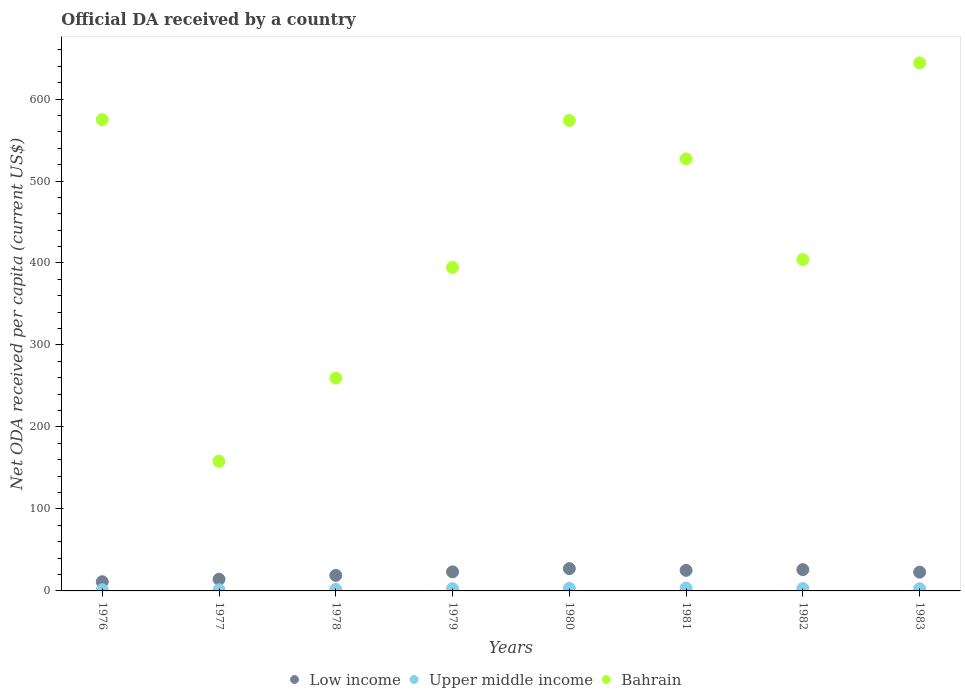What is the ODA received in in Bahrain in 1983?
Your response must be concise. 644.05. Across all years, what is the maximum ODA received in in Bahrain?
Offer a terse response. 644.05. Across all years, what is the minimum ODA received in in Low income?
Offer a terse response. 11.2. In which year was the ODA received in in Low income minimum?
Offer a very short reply. 1976. What is the total ODA received in in Bahrain in the graph?
Offer a very short reply. 3536.22. What is the difference between the ODA received in in Upper middle income in 1979 and that in 1982?
Offer a very short reply. -0.21. What is the difference between the ODA received in in Low income in 1978 and the ODA received in in Upper middle income in 1976?
Provide a succinct answer. 17.56. What is the average ODA received in in Upper middle income per year?
Your answer should be very brief. 2.47. In the year 1976, what is the difference between the ODA received in in Low income and ODA received in in Upper middle income?
Offer a terse response. 9.8. In how many years, is the ODA received in in Upper middle income greater than 560 US$?
Provide a short and direct response. 0. What is the ratio of the ODA received in in Upper middle income in 1982 to that in 1983?
Provide a short and direct response. 1.07. What is the difference between the highest and the second highest ODA received in in Low income?
Provide a short and direct response. 1.23. What is the difference between the highest and the lowest ODA received in in Low income?
Offer a very short reply. 15.99. In how many years, is the ODA received in in Bahrain greater than the average ODA received in in Bahrain taken over all years?
Make the answer very short. 4. Is the sum of the ODA received in in Bahrain in 1978 and 1982 greater than the maximum ODA received in in Low income across all years?
Provide a succinct answer. Yes. Does the ODA received in in Upper middle income monotonically increase over the years?
Provide a succinct answer. No. Is the ODA received in in Upper middle income strictly greater than the ODA received in in Low income over the years?
Your answer should be very brief. No. Is the ODA received in in Bahrain strictly less than the ODA received in in Upper middle income over the years?
Provide a succinct answer. No. How many dotlines are there?
Make the answer very short. 3. What is the difference between two consecutive major ticks on the Y-axis?
Keep it short and to the point. 100. Are the values on the major ticks of Y-axis written in scientific E-notation?
Provide a succinct answer. No. Does the graph contain any zero values?
Provide a short and direct response. No. What is the title of the graph?
Ensure brevity in your answer.  Official DA received by a country. What is the label or title of the Y-axis?
Your answer should be very brief. Net ODA received per capita (current US$). What is the Net ODA received per capita (current US$) of Low income in 1976?
Make the answer very short. 11.2. What is the Net ODA received per capita (current US$) in Upper middle income in 1976?
Your response must be concise. 1.4. What is the Net ODA received per capita (current US$) in Bahrain in 1976?
Your answer should be very brief. 574.82. What is the Net ODA received per capita (current US$) of Low income in 1977?
Provide a succinct answer. 14.23. What is the Net ODA received per capita (current US$) in Upper middle income in 1977?
Your answer should be compact. 1.33. What is the Net ODA received per capita (current US$) of Bahrain in 1977?
Your answer should be compact. 158.16. What is the Net ODA received per capita (current US$) in Low income in 1978?
Ensure brevity in your answer.  18.96. What is the Net ODA received per capita (current US$) of Upper middle income in 1978?
Ensure brevity in your answer.  1.85. What is the Net ODA received per capita (current US$) of Bahrain in 1978?
Your answer should be compact. 259.53. What is the Net ODA received per capita (current US$) of Low income in 1979?
Your answer should be compact. 23.27. What is the Net ODA received per capita (current US$) of Upper middle income in 1979?
Your answer should be very brief. 2.72. What is the Net ODA received per capita (current US$) in Bahrain in 1979?
Your answer should be compact. 394.63. What is the Net ODA received per capita (current US$) in Low income in 1980?
Provide a short and direct response. 27.18. What is the Net ODA received per capita (current US$) of Upper middle income in 1980?
Your answer should be compact. 3.27. What is the Net ODA received per capita (current US$) of Bahrain in 1980?
Keep it short and to the point. 573.85. What is the Net ODA received per capita (current US$) in Low income in 1981?
Offer a terse response. 25.1. What is the Net ODA received per capita (current US$) of Upper middle income in 1981?
Offer a terse response. 3.5. What is the Net ODA received per capita (current US$) in Bahrain in 1981?
Your answer should be compact. 526.99. What is the Net ODA received per capita (current US$) in Low income in 1982?
Your answer should be very brief. 25.95. What is the Net ODA received per capita (current US$) of Upper middle income in 1982?
Your response must be concise. 2.93. What is the Net ODA received per capita (current US$) in Bahrain in 1982?
Your response must be concise. 404.2. What is the Net ODA received per capita (current US$) in Low income in 1983?
Your answer should be compact. 22.9. What is the Net ODA received per capita (current US$) of Upper middle income in 1983?
Offer a very short reply. 2.74. What is the Net ODA received per capita (current US$) of Bahrain in 1983?
Make the answer very short. 644.05. Across all years, what is the maximum Net ODA received per capita (current US$) of Low income?
Your answer should be very brief. 27.18. Across all years, what is the maximum Net ODA received per capita (current US$) of Upper middle income?
Offer a terse response. 3.5. Across all years, what is the maximum Net ODA received per capita (current US$) in Bahrain?
Offer a very short reply. 644.05. Across all years, what is the minimum Net ODA received per capita (current US$) of Low income?
Provide a succinct answer. 11.2. Across all years, what is the minimum Net ODA received per capita (current US$) in Upper middle income?
Your answer should be compact. 1.33. Across all years, what is the minimum Net ODA received per capita (current US$) of Bahrain?
Your answer should be compact. 158.16. What is the total Net ODA received per capita (current US$) of Low income in the graph?
Your answer should be very brief. 168.79. What is the total Net ODA received per capita (current US$) in Upper middle income in the graph?
Give a very brief answer. 19.74. What is the total Net ODA received per capita (current US$) in Bahrain in the graph?
Your answer should be very brief. 3536.22. What is the difference between the Net ODA received per capita (current US$) of Low income in 1976 and that in 1977?
Your answer should be compact. -3.03. What is the difference between the Net ODA received per capita (current US$) of Upper middle income in 1976 and that in 1977?
Provide a short and direct response. 0.07. What is the difference between the Net ODA received per capita (current US$) of Bahrain in 1976 and that in 1977?
Offer a very short reply. 416.66. What is the difference between the Net ODA received per capita (current US$) in Low income in 1976 and that in 1978?
Provide a succinct answer. -7.76. What is the difference between the Net ODA received per capita (current US$) of Upper middle income in 1976 and that in 1978?
Offer a very short reply. -0.46. What is the difference between the Net ODA received per capita (current US$) in Bahrain in 1976 and that in 1978?
Offer a very short reply. 315.3. What is the difference between the Net ODA received per capita (current US$) in Low income in 1976 and that in 1979?
Offer a very short reply. -12.07. What is the difference between the Net ODA received per capita (current US$) in Upper middle income in 1976 and that in 1979?
Give a very brief answer. -1.32. What is the difference between the Net ODA received per capita (current US$) in Bahrain in 1976 and that in 1979?
Make the answer very short. 180.2. What is the difference between the Net ODA received per capita (current US$) of Low income in 1976 and that in 1980?
Your response must be concise. -15.99. What is the difference between the Net ODA received per capita (current US$) of Upper middle income in 1976 and that in 1980?
Ensure brevity in your answer.  -1.87. What is the difference between the Net ODA received per capita (current US$) of Bahrain in 1976 and that in 1980?
Give a very brief answer. 0.97. What is the difference between the Net ODA received per capita (current US$) of Low income in 1976 and that in 1981?
Your answer should be very brief. -13.9. What is the difference between the Net ODA received per capita (current US$) in Upper middle income in 1976 and that in 1981?
Make the answer very short. -2.1. What is the difference between the Net ODA received per capita (current US$) of Bahrain in 1976 and that in 1981?
Offer a very short reply. 47.84. What is the difference between the Net ODA received per capita (current US$) of Low income in 1976 and that in 1982?
Your answer should be compact. -14.75. What is the difference between the Net ODA received per capita (current US$) in Upper middle income in 1976 and that in 1982?
Provide a succinct answer. -1.53. What is the difference between the Net ODA received per capita (current US$) in Bahrain in 1976 and that in 1982?
Your answer should be compact. 170.63. What is the difference between the Net ODA received per capita (current US$) in Low income in 1976 and that in 1983?
Keep it short and to the point. -11.71. What is the difference between the Net ODA received per capita (current US$) of Upper middle income in 1976 and that in 1983?
Provide a short and direct response. -1.35. What is the difference between the Net ODA received per capita (current US$) in Bahrain in 1976 and that in 1983?
Give a very brief answer. -69.22. What is the difference between the Net ODA received per capita (current US$) in Low income in 1977 and that in 1978?
Offer a very short reply. -4.73. What is the difference between the Net ODA received per capita (current US$) in Upper middle income in 1977 and that in 1978?
Provide a succinct answer. -0.53. What is the difference between the Net ODA received per capita (current US$) of Bahrain in 1977 and that in 1978?
Make the answer very short. -101.37. What is the difference between the Net ODA received per capita (current US$) of Low income in 1977 and that in 1979?
Give a very brief answer. -9.04. What is the difference between the Net ODA received per capita (current US$) of Upper middle income in 1977 and that in 1979?
Keep it short and to the point. -1.39. What is the difference between the Net ODA received per capita (current US$) in Bahrain in 1977 and that in 1979?
Offer a terse response. -236.47. What is the difference between the Net ODA received per capita (current US$) of Low income in 1977 and that in 1980?
Keep it short and to the point. -12.96. What is the difference between the Net ODA received per capita (current US$) in Upper middle income in 1977 and that in 1980?
Ensure brevity in your answer.  -1.94. What is the difference between the Net ODA received per capita (current US$) of Bahrain in 1977 and that in 1980?
Make the answer very short. -415.69. What is the difference between the Net ODA received per capita (current US$) of Low income in 1977 and that in 1981?
Provide a succinct answer. -10.88. What is the difference between the Net ODA received per capita (current US$) in Upper middle income in 1977 and that in 1981?
Offer a very short reply. -2.17. What is the difference between the Net ODA received per capita (current US$) in Bahrain in 1977 and that in 1981?
Your answer should be very brief. -368.83. What is the difference between the Net ODA received per capita (current US$) of Low income in 1977 and that in 1982?
Your answer should be very brief. -11.73. What is the difference between the Net ODA received per capita (current US$) in Upper middle income in 1977 and that in 1982?
Provide a succinct answer. -1.6. What is the difference between the Net ODA received per capita (current US$) in Bahrain in 1977 and that in 1982?
Offer a very short reply. -246.04. What is the difference between the Net ODA received per capita (current US$) of Low income in 1977 and that in 1983?
Provide a short and direct response. -8.68. What is the difference between the Net ODA received per capita (current US$) of Upper middle income in 1977 and that in 1983?
Ensure brevity in your answer.  -1.41. What is the difference between the Net ODA received per capita (current US$) in Bahrain in 1977 and that in 1983?
Keep it short and to the point. -485.89. What is the difference between the Net ODA received per capita (current US$) of Low income in 1978 and that in 1979?
Your answer should be very brief. -4.31. What is the difference between the Net ODA received per capita (current US$) in Upper middle income in 1978 and that in 1979?
Your answer should be compact. -0.87. What is the difference between the Net ODA received per capita (current US$) in Bahrain in 1978 and that in 1979?
Your answer should be very brief. -135.1. What is the difference between the Net ODA received per capita (current US$) in Low income in 1978 and that in 1980?
Provide a succinct answer. -8.23. What is the difference between the Net ODA received per capita (current US$) in Upper middle income in 1978 and that in 1980?
Keep it short and to the point. -1.41. What is the difference between the Net ODA received per capita (current US$) in Bahrain in 1978 and that in 1980?
Offer a terse response. -314.32. What is the difference between the Net ODA received per capita (current US$) of Low income in 1978 and that in 1981?
Give a very brief answer. -6.14. What is the difference between the Net ODA received per capita (current US$) of Upper middle income in 1978 and that in 1981?
Your response must be concise. -1.64. What is the difference between the Net ODA received per capita (current US$) of Bahrain in 1978 and that in 1981?
Your answer should be very brief. -267.46. What is the difference between the Net ODA received per capita (current US$) of Low income in 1978 and that in 1982?
Make the answer very short. -6.99. What is the difference between the Net ODA received per capita (current US$) in Upper middle income in 1978 and that in 1982?
Give a very brief answer. -1.07. What is the difference between the Net ODA received per capita (current US$) of Bahrain in 1978 and that in 1982?
Provide a short and direct response. -144.67. What is the difference between the Net ODA received per capita (current US$) of Low income in 1978 and that in 1983?
Keep it short and to the point. -3.95. What is the difference between the Net ODA received per capita (current US$) of Upper middle income in 1978 and that in 1983?
Your response must be concise. -0.89. What is the difference between the Net ODA received per capita (current US$) of Bahrain in 1978 and that in 1983?
Make the answer very short. -384.52. What is the difference between the Net ODA received per capita (current US$) of Low income in 1979 and that in 1980?
Your response must be concise. -3.92. What is the difference between the Net ODA received per capita (current US$) of Upper middle income in 1979 and that in 1980?
Provide a short and direct response. -0.55. What is the difference between the Net ODA received per capita (current US$) of Bahrain in 1979 and that in 1980?
Your answer should be compact. -179.22. What is the difference between the Net ODA received per capita (current US$) in Low income in 1979 and that in 1981?
Make the answer very short. -1.83. What is the difference between the Net ODA received per capita (current US$) of Upper middle income in 1979 and that in 1981?
Your answer should be compact. -0.78. What is the difference between the Net ODA received per capita (current US$) of Bahrain in 1979 and that in 1981?
Your answer should be very brief. -132.36. What is the difference between the Net ODA received per capita (current US$) in Low income in 1979 and that in 1982?
Give a very brief answer. -2.68. What is the difference between the Net ODA received per capita (current US$) in Upper middle income in 1979 and that in 1982?
Provide a succinct answer. -0.21. What is the difference between the Net ODA received per capita (current US$) of Bahrain in 1979 and that in 1982?
Provide a short and direct response. -9.57. What is the difference between the Net ODA received per capita (current US$) of Low income in 1979 and that in 1983?
Your answer should be very brief. 0.36. What is the difference between the Net ODA received per capita (current US$) in Upper middle income in 1979 and that in 1983?
Your response must be concise. -0.02. What is the difference between the Net ODA received per capita (current US$) in Bahrain in 1979 and that in 1983?
Your answer should be very brief. -249.42. What is the difference between the Net ODA received per capita (current US$) of Low income in 1980 and that in 1981?
Your response must be concise. 2.08. What is the difference between the Net ODA received per capita (current US$) of Upper middle income in 1980 and that in 1981?
Your answer should be compact. -0.23. What is the difference between the Net ODA received per capita (current US$) of Bahrain in 1980 and that in 1981?
Keep it short and to the point. 46.86. What is the difference between the Net ODA received per capita (current US$) of Low income in 1980 and that in 1982?
Provide a short and direct response. 1.23. What is the difference between the Net ODA received per capita (current US$) of Upper middle income in 1980 and that in 1982?
Your answer should be very brief. 0.34. What is the difference between the Net ODA received per capita (current US$) of Bahrain in 1980 and that in 1982?
Your answer should be very brief. 169.65. What is the difference between the Net ODA received per capita (current US$) in Low income in 1980 and that in 1983?
Offer a terse response. 4.28. What is the difference between the Net ODA received per capita (current US$) of Upper middle income in 1980 and that in 1983?
Give a very brief answer. 0.53. What is the difference between the Net ODA received per capita (current US$) of Bahrain in 1980 and that in 1983?
Your response must be concise. -70.2. What is the difference between the Net ODA received per capita (current US$) of Low income in 1981 and that in 1982?
Provide a succinct answer. -0.85. What is the difference between the Net ODA received per capita (current US$) in Upper middle income in 1981 and that in 1982?
Ensure brevity in your answer.  0.57. What is the difference between the Net ODA received per capita (current US$) of Bahrain in 1981 and that in 1982?
Provide a succinct answer. 122.79. What is the difference between the Net ODA received per capita (current US$) of Low income in 1981 and that in 1983?
Provide a short and direct response. 2.2. What is the difference between the Net ODA received per capita (current US$) in Upper middle income in 1981 and that in 1983?
Your answer should be very brief. 0.76. What is the difference between the Net ODA received per capita (current US$) of Bahrain in 1981 and that in 1983?
Your response must be concise. -117.06. What is the difference between the Net ODA received per capita (current US$) of Low income in 1982 and that in 1983?
Your answer should be compact. 3.05. What is the difference between the Net ODA received per capita (current US$) of Upper middle income in 1982 and that in 1983?
Ensure brevity in your answer.  0.18. What is the difference between the Net ODA received per capita (current US$) of Bahrain in 1982 and that in 1983?
Ensure brevity in your answer.  -239.85. What is the difference between the Net ODA received per capita (current US$) of Low income in 1976 and the Net ODA received per capita (current US$) of Upper middle income in 1977?
Give a very brief answer. 9.87. What is the difference between the Net ODA received per capita (current US$) in Low income in 1976 and the Net ODA received per capita (current US$) in Bahrain in 1977?
Provide a succinct answer. -146.96. What is the difference between the Net ODA received per capita (current US$) of Upper middle income in 1976 and the Net ODA received per capita (current US$) of Bahrain in 1977?
Offer a very short reply. -156.76. What is the difference between the Net ODA received per capita (current US$) of Low income in 1976 and the Net ODA received per capita (current US$) of Upper middle income in 1978?
Offer a terse response. 9.34. What is the difference between the Net ODA received per capita (current US$) in Low income in 1976 and the Net ODA received per capita (current US$) in Bahrain in 1978?
Give a very brief answer. -248.33. What is the difference between the Net ODA received per capita (current US$) in Upper middle income in 1976 and the Net ODA received per capita (current US$) in Bahrain in 1978?
Make the answer very short. -258.13. What is the difference between the Net ODA received per capita (current US$) of Low income in 1976 and the Net ODA received per capita (current US$) of Upper middle income in 1979?
Your answer should be very brief. 8.48. What is the difference between the Net ODA received per capita (current US$) in Low income in 1976 and the Net ODA received per capita (current US$) in Bahrain in 1979?
Make the answer very short. -383.43. What is the difference between the Net ODA received per capita (current US$) in Upper middle income in 1976 and the Net ODA received per capita (current US$) in Bahrain in 1979?
Make the answer very short. -393.23. What is the difference between the Net ODA received per capita (current US$) of Low income in 1976 and the Net ODA received per capita (current US$) of Upper middle income in 1980?
Your response must be concise. 7.93. What is the difference between the Net ODA received per capita (current US$) of Low income in 1976 and the Net ODA received per capita (current US$) of Bahrain in 1980?
Keep it short and to the point. -562.65. What is the difference between the Net ODA received per capita (current US$) of Upper middle income in 1976 and the Net ODA received per capita (current US$) of Bahrain in 1980?
Make the answer very short. -572.45. What is the difference between the Net ODA received per capita (current US$) in Low income in 1976 and the Net ODA received per capita (current US$) in Upper middle income in 1981?
Your response must be concise. 7.7. What is the difference between the Net ODA received per capita (current US$) in Low income in 1976 and the Net ODA received per capita (current US$) in Bahrain in 1981?
Offer a terse response. -515.79. What is the difference between the Net ODA received per capita (current US$) in Upper middle income in 1976 and the Net ODA received per capita (current US$) in Bahrain in 1981?
Your response must be concise. -525.59. What is the difference between the Net ODA received per capita (current US$) in Low income in 1976 and the Net ODA received per capita (current US$) in Upper middle income in 1982?
Offer a very short reply. 8.27. What is the difference between the Net ODA received per capita (current US$) in Low income in 1976 and the Net ODA received per capita (current US$) in Bahrain in 1982?
Your answer should be compact. -393. What is the difference between the Net ODA received per capita (current US$) in Upper middle income in 1976 and the Net ODA received per capita (current US$) in Bahrain in 1982?
Keep it short and to the point. -402.8. What is the difference between the Net ODA received per capita (current US$) in Low income in 1976 and the Net ODA received per capita (current US$) in Upper middle income in 1983?
Your response must be concise. 8.46. What is the difference between the Net ODA received per capita (current US$) in Low income in 1976 and the Net ODA received per capita (current US$) in Bahrain in 1983?
Offer a terse response. -632.85. What is the difference between the Net ODA received per capita (current US$) in Upper middle income in 1976 and the Net ODA received per capita (current US$) in Bahrain in 1983?
Offer a terse response. -642.65. What is the difference between the Net ODA received per capita (current US$) of Low income in 1977 and the Net ODA received per capita (current US$) of Upper middle income in 1978?
Your answer should be very brief. 12.37. What is the difference between the Net ODA received per capita (current US$) of Low income in 1977 and the Net ODA received per capita (current US$) of Bahrain in 1978?
Provide a short and direct response. -245.3. What is the difference between the Net ODA received per capita (current US$) in Upper middle income in 1977 and the Net ODA received per capita (current US$) in Bahrain in 1978?
Provide a succinct answer. -258.2. What is the difference between the Net ODA received per capita (current US$) in Low income in 1977 and the Net ODA received per capita (current US$) in Upper middle income in 1979?
Offer a very short reply. 11.5. What is the difference between the Net ODA received per capita (current US$) of Low income in 1977 and the Net ODA received per capita (current US$) of Bahrain in 1979?
Your answer should be very brief. -380.4. What is the difference between the Net ODA received per capita (current US$) in Upper middle income in 1977 and the Net ODA received per capita (current US$) in Bahrain in 1979?
Your answer should be very brief. -393.3. What is the difference between the Net ODA received per capita (current US$) of Low income in 1977 and the Net ODA received per capita (current US$) of Upper middle income in 1980?
Provide a succinct answer. 10.96. What is the difference between the Net ODA received per capita (current US$) of Low income in 1977 and the Net ODA received per capita (current US$) of Bahrain in 1980?
Your answer should be compact. -559.63. What is the difference between the Net ODA received per capita (current US$) in Upper middle income in 1977 and the Net ODA received per capita (current US$) in Bahrain in 1980?
Ensure brevity in your answer.  -572.52. What is the difference between the Net ODA received per capita (current US$) in Low income in 1977 and the Net ODA received per capita (current US$) in Upper middle income in 1981?
Offer a very short reply. 10.73. What is the difference between the Net ODA received per capita (current US$) of Low income in 1977 and the Net ODA received per capita (current US$) of Bahrain in 1981?
Give a very brief answer. -512.76. What is the difference between the Net ODA received per capita (current US$) of Upper middle income in 1977 and the Net ODA received per capita (current US$) of Bahrain in 1981?
Provide a short and direct response. -525.66. What is the difference between the Net ODA received per capita (current US$) of Low income in 1977 and the Net ODA received per capita (current US$) of Upper middle income in 1982?
Offer a very short reply. 11.3. What is the difference between the Net ODA received per capita (current US$) in Low income in 1977 and the Net ODA received per capita (current US$) in Bahrain in 1982?
Provide a short and direct response. -389.97. What is the difference between the Net ODA received per capita (current US$) in Upper middle income in 1977 and the Net ODA received per capita (current US$) in Bahrain in 1982?
Offer a terse response. -402.87. What is the difference between the Net ODA received per capita (current US$) of Low income in 1977 and the Net ODA received per capita (current US$) of Upper middle income in 1983?
Keep it short and to the point. 11.48. What is the difference between the Net ODA received per capita (current US$) in Low income in 1977 and the Net ODA received per capita (current US$) in Bahrain in 1983?
Make the answer very short. -629.82. What is the difference between the Net ODA received per capita (current US$) in Upper middle income in 1977 and the Net ODA received per capita (current US$) in Bahrain in 1983?
Offer a very short reply. -642.72. What is the difference between the Net ODA received per capita (current US$) of Low income in 1978 and the Net ODA received per capita (current US$) of Upper middle income in 1979?
Your answer should be very brief. 16.24. What is the difference between the Net ODA received per capita (current US$) of Low income in 1978 and the Net ODA received per capita (current US$) of Bahrain in 1979?
Provide a succinct answer. -375.67. What is the difference between the Net ODA received per capita (current US$) of Upper middle income in 1978 and the Net ODA received per capita (current US$) of Bahrain in 1979?
Give a very brief answer. -392.77. What is the difference between the Net ODA received per capita (current US$) in Low income in 1978 and the Net ODA received per capita (current US$) in Upper middle income in 1980?
Your answer should be very brief. 15.69. What is the difference between the Net ODA received per capita (current US$) in Low income in 1978 and the Net ODA received per capita (current US$) in Bahrain in 1980?
Your answer should be compact. -554.89. What is the difference between the Net ODA received per capita (current US$) of Upper middle income in 1978 and the Net ODA received per capita (current US$) of Bahrain in 1980?
Provide a succinct answer. -572. What is the difference between the Net ODA received per capita (current US$) of Low income in 1978 and the Net ODA received per capita (current US$) of Upper middle income in 1981?
Your response must be concise. 15.46. What is the difference between the Net ODA received per capita (current US$) in Low income in 1978 and the Net ODA received per capita (current US$) in Bahrain in 1981?
Make the answer very short. -508.03. What is the difference between the Net ODA received per capita (current US$) in Upper middle income in 1978 and the Net ODA received per capita (current US$) in Bahrain in 1981?
Offer a terse response. -525.14. What is the difference between the Net ODA received per capita (current US$) in Low income in 1978 and the Net ODA received per capita (current US$) in Upper middle income in 1982?
Give a very brief answer. 16.03. What is the difference between the Net ODA received per capita (current US$) in Low income in 1978 and the Net ODA received per capita (current US$) in Bahrain in 1982?
Provide a short and direct response. -385.24. What is the difference between the Net ODA received per capita (current US$) in Upper middle income in 1978 and the Net ODA received per capita (current US$) in Bahrain in 1982?
Offer a terse response. -402.34. What is the difference between the Net ODA received per capita (current US$) of Low income in 1978 and the Net ODA received per capita (current US$) of Upper middle income in 1983?
Make the answer very short. 16.22. What is the difference between the Net ODA received per capita (current US$) in Low income in 1978 and the Net ODA received per capita (current US$) in Bahrain in 1983?
Provide a succinct answer. -625.09. What is the difference between the Net ODA received per capita (current US$) of Upper middle income in 1978 and the Net ODA received per capita (current US$) of Bahrain in 1983?
Offer a terse response. -642.19. What is the difference between the Net ODA received per capita (current US$) of Low income in 1979 and the Net ODA received per capita (current US$) of Upper middle income in 1980?
Keep it short and to the point. 20. What is the difference between the Net ODA received per capita (current US$) of Low income in 1979 and the Net ODA received per capita (current US$) of Bahrain in 1980?
Offer a terse response. -550.58. What is the difference between the Net ODA received per capita (current US$) of Upper middle income in 1979 and the Net ODA received per capita (current US$) of Bahrain in 1980?
Make the answer very short. -571.13. What is the difference between the Net ODA received per capita (current US$) of Low income in 1979 and the Net ODA received per capita (current US$) of Upper middle income in 1981?
Your response must be concise. 19.77. What is the difference between the Net ODA received per capita (current US$) in Low income in 1979 and the Net ODA received per capita (current US$) in Bahrain in 1981?
Your answer should be compact. -503.72. What is the difference between the Net ODA received per capita (current US$) of Upper middle income in 1979 and the Net ODA received per capita (current US$) of Bahrain in 1981?
Ensure brevity in your answer.  -524.27. What is the difference between the Net ODA received per capita (current US$) of Low income in 1979 and the Net ODA received per capita (current US$) of Upper middle income in 1982?
Provide a short and direct response. 20.34. What is the difference between the Net ODA received per capita (current US$) of Low income in 1979 and the Net ODA received per capita (current US$) of Bahrain in 1982?
Keep it short and to the point. -380.93. What is the difference between the Net ODA received per capita (current US$) of Upper middle income in 1979 and the Net ODA received per capita (current US$) of Bahrain in 1982?
Offer a very short reply. -401.48. What is the difference between the Net ODA received per capita (current US$) of Low income in 1979 and the Net ODA received per capita (current US$) of Upper middle income in 1983?
Give a very brief answer. 20.52. What is the difference between the Net ODA received per capita (current US$) of Low income in 1979 and the Net ODA received per capita (current US$) of Bahrain in 1983?
Give a very brief answer. -620.78. What is the difference between the Net ODA received per capita (current US$) of Upper middle income in 1979 and the Net ODA received per capita (current US$) of Bahrain in 1983?
Provide a succinct answer. -641.32. What is the difference between the Net ODA received per capita (current US$) of Low income in 1980 and the Net ODA received per capita (current US$) of Upper middle income in 1981?
Provide a succinct answer. 23.69. What is the difference between the Net ODA received per capita (current US$) of Low income in 1980 and the Net ODA received per capita (current US$) of Bahrain in 1981?
Ensure brevity in your answer.  -499.8. What is the difference between the Net ODA received per capita (current US$) in Upper middle income in 1980 and the Net ODA received per capita (current US$) in Bahrain in 1981?
Keep it short and to the point. -523.72. What is the difference between the Net ODA received per capita (current US$) of Low income in 1980 and the Net ODA received per capita (current US$) of Upper middle income in 1982?
Your answer should be compact. 24.26. What is the difference between the Net ODA received per capita (current US$) of Low income in 1980 and the Net ODA received per capita (current US$) of Bahrain in 1982?
Your response must be concise. -377.01. What is the difference between the Net ODA received per capita (current US$) in Upper middle income in 1980 and the Net ODA received per capita (current US$) in Bahrain in 1982?
Offer a terse response. -400.93. What is the difference between the Net ODA received per capita (current US$) in Low income in 1980 and the Net ODA received per capita (current US$) in Upper middle income in 1983?
Give a very brief answer. 24.44. What is the difference between the Net ODA received per capita (current US$) in Low income in 1980 and the Net ODA received per capita (current US$) in Bahrain in 1983?
Your answer should be very brief. -616.86. What is the difference between the Net ODA received per capita (current US$) in Upper middle income in 1980 and the Net ODA received per capita (current US$) in Bahrain in 1983?
Your answer should be compact. -640.78. What is the difference between the Net ODA received per capita (current US$) in Low income in 1981 and the Net ODA received per capita (current US$) in Upper middle income in 1982?
Keep it short and to the point. 22.17. What is the difference between the Net ODA received per capita (current US$) in Low income in 1981 and the Net ODA received per capita (current US$) in Bahrain in 1982?
Ensure brevity in your answer.  -379.1. What is the difference between the Net ODA received per capita (current US$) in Upper middle income in 1981 and the Net ODA received per capita (current US$) in Bahrain in 1982?
Your answer should be very brief. -400.7. What is the difference between the Net ODA received per capita (current US$) in Low income in 1981 and the Net ODA received per capita (current US$) in Upper middle income in 1983?
Provide a short and direct response. 22.36. What is the difference between the Net ODA received per capita (current US$) of Low income in 1981 and the Net ODA received per capita (current US$) of Bahrain in 1983?
Your answer should be very brief. -618.94. What is the difference between the Net ODA received per capita (current US$) of Upper middle income in 1981 and the Net ODA received per capita (current US$) of Bahrain in 1983?
Provide a succinct answer. -640.55. What is the difference between the Net ODA received per capita (current US$) in Low income in 1982 and the Net ODA received per capita (current US$) in Upper middle income in 1983?
Keep it short and to the point. 23.21. What is the difference between the Net ODA received per capita (current US$) in Low income in 1982 and the Net ODA received per capita (current US$) in Bahrain in 1983?
Your response must be concise. -618.09. What is the difference between the Net ODA received per capita (current US$) of Upper middle income in 1982 and the Net ODA received per capita (current US$) of Bahrain in 1983?
Ensure brevity in your answer.  -641.12. What is the average Net ODA received per capita (current US$) of Low income per year?
Your answer should be very brief. 21.1. What is the average Net ODA received per capita (current US$) of Upper middle income per year?
Offer a terse response. 2.47. What is the average Net ODA received per capita (current US$) of Bahrain per year?
Offer a terse response. 442.03. In the year 1976, what is the difference between the Net ODA received per capita (current US$) in Low income and Net ODA received per capita (current US$) in Upper middle income?
Provide a succinct answer. 9.8. In the year 1976, what is the difference between the Net ODA received per capita (current US$) of Low income and Net ODA received per capita (current US$) of Bahrain?
Ensure brevity in your answer.  -563.63. In the year 1976, what is the difference between the Net ODA received per capita (current US$) in Upper middle income and Net ODA received per capita (current US$) in Bahrain?
Offer a very short reply. -573.43. In the year 1977, what is the difference between the Net ODA received per capita (current US$) of Low income and Net ODA received per capita (current US$) of Upper middle income?
Make the answer very short. 12.9. In the year 1977, what is the difference between the Net ODA received per capita (current US$) of Low income and Net ODA received per capita (current US$) of Bahrain?
Offer a terse response. -143.94. In the year 1977, what is the difference between the Net ODA received per capita (current US$) in Upper middle income and Net ODA received per capita (current US$) in Bahrain?
Provide a succinct answer. -156.83. In the year 1978, what is the difference between the Net ODA received per capita (current US$) in Low income and Net ODA received per capita (current US$) in Upper middle income?
Provide a short and direct response. 17.1. In the year 1978, what is the difference between the Net ODA received per capita (current US$) of Low income and Net ODA received per capita (current US$) of Bahrain?
Offer a terse response. -240.57. In the year 1978, what is the difference between the Net ODA received per capita (current US$) of Upper middle income and Net ODA received per capita (current US$) of Bahrain?
Make the answer very short. -257.67. In the year 1979, what is the difference between the Net ODA received per capita (current US$) in Low income and Net ODA received per capita (current US$) in Upper middle income?
Provide a short and direct response. 20.55. In the year 1979, what is the difference between the Net ODA received per capita (current US$) of Low income and Net ODA received per capita (current US$) of Bahrain?
Ensure brevity in your answer.  -371.36. In the year 1979, what is the difference between the Net ODA received per capita (current US$) in Upper middle income and Net ODA received per capita (current US$) in Bahrain?
Offer a very short reply. -391.91. In the year 1980, what is the difference between the Net ODA received per capita (current US$) of Low income and Net ODA received per capita (current US$) of Upper middle income?
Provide a succinct answer. 23.92. In the year 1980, what is the difference between the Net ODA received per capita (current US$) in Low income and Net ODA received per capita (current US$) in Bahrain?
Ensure brevity in your answer.  -546.67. In the year 1980, what is the difference between the Net ODA received per capita (current US$) in Upper middle income and Net ODA received per capita (current US$) in Bahrain?
Your response must be concise. -570.58. In the year 1981, what is the difference between the Net ODA received per capita (current US$) in Low income and Net ODA received per capita (current US$) in Upper middle income?
Your response must be concise. 21.6. In the year 1981, what is the difference between the Net ODA received per capita (current US$) of Low income and Net ODA received per capita (current US$) of Bahrain?
Your response must be concise. -501.89. In the year 1981, what is the difference between the Net ODA received per capita (current US$) of Upper middle income and Net ODA received per capita (current US$) of Bahrain?
Your response must be concise. -523.49. In the year 1982, what is the difference between the Net ODA received per capita (current US$) in Low income and Net ODA received per capita (current US$) in Upper middle income?
Your answer should be very brief. 23.02. In the year 1982, what is the difference between the Net ODA received per capita (current US$) in Low income and Net ODA received per capita (current US$) in Bahrain?
Provide a succinct answer. -378.25. In the year 1982, what is the difference between the Net ODA received per capita (current US$) in Upper middle income and Net ODA received per capita (current US$) in Bahrain?
Provide a succinct answer. -401.27. In the year 1983, what is the difference between the Net ODA received per capita (current US$) in Low income and Net ODA received per capita (current US$) in Upper middle income?
Offer a very short reply. 20.16. In the year 1983, what is the difference between the Net ODA received per capita (current US$) in Low income and Net ODA received per capita (current US$) in Bahrain?
Provide a succinct answer. -621.14. In the year 1983, what is the difference between the Net ODA received per capita (current US$) in Upper middle income and Net ODA received per capita (current US$) in Bahrain?
Keep it short and to the point. -641.3. What is the ratio of the Net ODA received per capita (current US$) in Low income in 1976 to that in 1977?
Your response must be concise. 0.79. What is the ratio of the Net ODA received per capita (current US$) in Upper middle income in 1976 to that in 1977?
Your answer should be very brief. 1.05. What is the ratio of the Net ODA received per capita (current US$) in Bahrain in 1976 to that in 1977?
Your response must be concise. 3.63. What is the ratio of the Net ODA received per capita (current US$) in Low income in 1976 to that in 1978?
Keep it short and to the point. 0.59. What is the ratio of the Net ODA received per capita (current US$) of Upper middle income in 1976 to that in 1978?
Your answer should be very brief. 0.75. What is the ratio of the Net ODA received per capita (current US$) of Bahrain in 1976 to that in 1978?
Provide a succinct answer. 2.21. What is the ratio of the Net ODA received per capita (current US$) of Low income in 1976 to that in 1979?
Give a very brief answer. 0.48. What is the ratio of the Net ODA received per capita (current US$) in Upper middle income in 1976 to that in 1979?
Your response must be concise. 0.51. What is the ratio of the Net ODA received per capita (current US$) in Bahrain in 1976 to that in 1979?
Your response must be concise. 1.46. What is the ratio of the Net ODA received per capita (current US$) in Low income in 1976 to that in 1980?
Your answer should be very brief. 0.41. What is the ratio of the Net ODA received per capita (current US$) of Upper middle income in 1976 to that in 1980?
Provide a short and direct response. 0.43. What is the ratio of the Net ODA received per capita (current US$) in Bahrain in 1976 to that in 1980?
Your answer should be compact. 1. What is the ratio of the Net ODA received per capita (current US$) of Low income in 1976 to that in 1981?
Ensure brevity in your answer.  0.45. What is the ratio of the Net ODA received per capita (current US$) in Upper middle income in 1976 to that in 1981?
Provide a short and direct response. 0.4. What is the ratio of the Net ODA received per capita (current US$) of Bahrain in 1976 to that in 1981?
Your answer should be compact. 1.09. What is the ratio of the Net ODA received per capita (current US$) in Low income in 1976 to that in 1982?
Provide a succinct answer. 0.43. What is the ratio of the Net ODA received per capita (current US$) in Upper middle income in 1976 to that in 1982?
Ensure brevity in your answer.  0.48. What is the ratio of the Net ODA received per capita (current US$) in Bahrain in 1976 to that in 1982?
Provide a succinct answer. 1.42. What is the ratio of the Net ODA received per capita (current US$) of Low income in 1976 to that in 1983?
Keep it short and to the point. 0.49. What is the ratio of the Net ODA received per capita (current US$) of Upper middle income in 1976 to that in 1983?
Your answer should be compact. 0.51. What is the ratio of the Net ODA received per capita (current US$) in Bahrain in 1976 to that in 1983?
Your answer should be compact. 0.89. What is the ratio of the Net ODA received per capita (current US$) in Low income in 1977 to that in 1978?
Your answer should be compact. 0.75. What is the ratio of the Net ODA received per capita (current US$) of Upper middle income in 1977 to that in 1978?
Offer a terse response. 0.72. What is the ratio of the Net ODA received per capita (current US$) in Bahrain in 1977 to that in 1978?
Your answer should be very brief. 0.61. What is the ratio of the Net ODA received per capita (current US$) in Low income in 1977 to that in 1979?
Offer a very short reply. 0.61. What is the ratio of the Net ODA received per capita (current US$) of Upper middle income in 1977 to that in 1979?
Your answer should be compact. 0.49. What is the ratio of the Net ODA received per capita (current US$) in Bahrain in 1977 to that in 1979?
Your answer should be very brief. 0.4. What is the ratio of the Net ODA received per capita (current US$) in Low income in 1977 to that in 1980?
Your answer should be compact. 0.52. What is the ratio of the Net ODA received per capita (current US$) of Upper middle income in 1977 to that in 1980?
Your answer should be compact. 0.41. What is the ratio of the Net ODA received per capita (current US$) of Bahrain in 1977 to that in 1980?
Make the answer very short. 0.28. What is the ratio of the Net ODA received per capita (current US$) in Low income in 1977 to that in 1981?
Provide a succinct answer. 0.57. What is the ratio of the Net ODA received per capita (current US$) of Upper middle income in 1977 to that in 1981?
Provide a short and direct response. 0.38. What is the ratio of the Net ODA received per capita (current US$) in Bahrain in 1977 to that in 1981?
Offer a terse response. 0.3. What is the ratio of the Net ODA received per capita (current US$) in Low income in 1977 to that in 1982?
Ensure brevity in your answer.  0.55. What is the ratio of the Net ODA received per capita (current US$) of Upper middle income in 1977 to that in 1982?
Make the answer very short. 0.45. What is the ratio of the Net ODA received per capita (current US$) in Bahrain in 1977 to that in 1982?
Your response must be concise. 0.39. What is the ratio of the Net ODA received per capita (current US$) in Low income in 1977 to that in 1983?
Your answer should be very brief. 0.62. What is the ratio of the Net ODA received per capita (current US$) of Upper middle income in 1977 to that in 1983?
Your answer should be very brief. 0.48. What is the ratio of the Net ODA received per capita (current US$) in Bahrain in 1977 to that in 1983?
Your answer should be compact. 0.25. What is the ratio of the Net ODA received per capita (current US$) in Low income in 1978 to that in 1979?
Offer a very short reply. 0.81. What is the ratio of the Net ODA received per capita (current US$) in Upper middle income in 1978 to that in 1979?
Your answer should be compact. 0.68. What is the ratio of the Net ODA received per capita (current US$) of Bahrain in 1978 to that in 1979?
Your answer should be very brief. 0.66. What is the ratio of the Net ODA received per capita (current US$) of Low income in 1978 to that in 1980?
Your response must be concise. 0.7. What is the ratio of the Net ODA received per capita (current US$) of Upper middle income in 1978 to that in 1980?
Provide a short and direct response. 0.57. What is the ratio of the Net ODA received per capita (current US$) in Bahrain in 1978 to that in 1980?
Offer a very short reply. 0.45. What is the ratio of the Net ODA received per capita (current US$) of Low income in 1978 to that in 1981?
Make the answer very short. 0.76. What is the ratio of the Net ODA received per capita (current US$) of Upper middle income in 1978 to that in 1981?
Offer a terse response. 0.53. What is the ratio of the Net ODA received per capita (current US$) of Bahrain in 1978 to that in 1981?
Offer a terse response. 0.49. What is the ratio of the Net ODA received per capita (current US$) of Low income in 1978 to that in 1982?
Offer a very short reply. 0.73. What is the ratio of the Net ODA received per capita (current US$) in Upper middle income in 1978 to that in 1982?
Ensure brevity in your answer.  0.63. What is the ratio of the Net ODA received per capita (current US$) in Bahrain in 1978 to that in 1982?
Your answer should be very brief. 0.64. What is the ratio of the Net ODA received per capita (current US$) in Low income in 1978 to that in 1983?
Your answer should be compact. 0.83. What is the ratio of the Net ODA received per capita (current US$) in Upper middle income in 1978 to that in 1983?
Your answer should be compact. 0.68. What is the ratio of the Net ODA received per capita (current US$) in Bahrain in 1978 to that in 1983?
Make the answer very short. 0.4. What is the ratio of the Net ODA received per capita (current US$) in Low income in 1979 to that in 1980?
Ensure brevity in your answer.  0.86. What is the ratio of the Net ODA received per capita (current US$) in Upper middle income in 1979 to that in 1980?
Offer a very short reply. 0.83. What is the ratio of the Net ODA received per capita (current US$) in Bahrain in 1979 to that in 1980?
Offer a terse response. 0.69. What is the ratio of the Net ODA received per capita (current US$) of Low income in 1979 to that in 1981?
Your answer should be compact. 0.93. What is the ratio of the Net ODA received per capita (current US$) in Upper middle income in 1979 to that in 1981?
Make the answer very short. 0.78. What is the ratio of the Net ODA received per capita (current US$) in Bahrain in 1979 to that in 1981?
Offer a very short reply. 0.75. What is the ratio of the Net ODA received per capita (current US$) in Low income in 1979 to that in 1982?
Provide a succinct answer. 0.9. What is the ratio of the Net ODA received per capita (current US$) of Upper middle income in 1979 to that in 1982?
Your response must be concise. 0.93. What is the ratio of the Net ODA received per capita (current US$) in Bahrain in 1979 to that in 1982?
Your answer should be very brief. 0.98. What is the ratio of the Net ODA received per capita (current US$) of Low income in 1979 to that in 1983?
Make the answer very short. 1.02. What is the ratio of the Net ODA received per capita (current US$) in Upper middle income in 1979 to that in 1983?
Offer a very short reply. 0.99. What is the ratio of the Net ODA received per capita (current US$) in Bahrain in 1979 to that in 1983?
Keep it short and to the point. 0.61. What is the ratio of the Net ODA received per capita (current US$) of Low income in 1980 to that in 1981?
Offer a terse response. 1.08. What is the ratio of the Net ODA received per capita (current US$) in Upper middle income in 1980 to that in 1981?
Provide a succinct answer. 0.93. What is the ratio of the Net ODA received per capita (current US$) of Bahrain in 1980 to that in 1981?
Provide a succinct answer. 1.09. What is the ratio of the Net ODA received per capita (current US$) in Low income in 1980 to that in 1982?
Your answer should be compact. 1.05. What is the ratio of the Net ODA received per capita (current US$) of Upper middle income in 1980 to that in 1982?
Give a very brief answer. 1.12. What is the ratio of the Net ODA received per capita (current US$) in Bahrain in 1980 to that in 1982?
Give a very brief answer. 1.42. What is the ratio of the Net ODA received per capita (current US$) of Low income in 1980 to that in 1983?
Make the answer very short. 1.19. What is the ratio of the Net ODA received per capita (current US$) of Upper middle income in 1980 to that in 1983?
Provide a short and direct response. 1.19. What is the ratio of the Net ODA received per capita (current US$) of Bahrain in 1980 to that in 1983?
Give a very brief answer. 0.89. What is the ratio of the Net ODA received per capita (current US$) in Low income in 1981 to that in 1982?
Provide a short and direct response. 0.97. What is the ratio of the Net ODA received per capita (current US$) in Upper middle income in 1981 to that in 1982?
Give a very brief answer. 1.2. What is the ratio of the Net ODA received per capita (current US$) of Bahrain in 1981 to that in 1982?
Your response must be concise. 1.3. What is the ratio of the Net ODA received per capita (current US$) of Low income in 1981 to that in 1983?
Offer a very short reply. 1.1. What is the ratio of the Net ODA received per capita (current US$) of Upper middle income in 1981 to that in 1983?
Ensure brevity in your answer.  1.28. What is the ratio of the Net ODA received per capita (current US$) of Bahrain in 1981 to that in 1983?
Make the answer very short. 0.82. What is the ratio of the Net ODA received per capita (current US$) in Low income in 1982 to that in 1983?
Offer a terse response. 1.13. What is the ratio of the Net ODA received per capita (current US$) of Upper middle income in 1982 to that in 1983?
Keep it short and to the point. 1.07. What is the ratio of the Net ODA received per capita (current US$) in Bahrain in 1982 to that in 1983?
Offer a terse response. 0.63. What is the difference between the highest and the second highest Net ODA received per capita (current US$) in Low income?
Ensure brevity in your answer.  1.23. What is the difference between the highest and the second highest Net ODA received per capita (current US$) in Upper middle income?
Offer a very short reply. 0.23. What is the difference between the highest and the second highest Net ODA received per capita (current US$) in Bahrain?
Provide a short and direct response. 69.22. What is the difference between the highest and the lowest Net ODA received per capita (current US$) in Low income?
Make the answer very short. 15.99. What is the difference between the highest and the lowest Net ODA received per capita (current US$) in Upper middle income?
Provide a short and direct response. 2.17. What is the difference between the highest and the lowest Net ODA received per capita (current US$) of Bahrain?
Offer a very short reply. 485.89. 